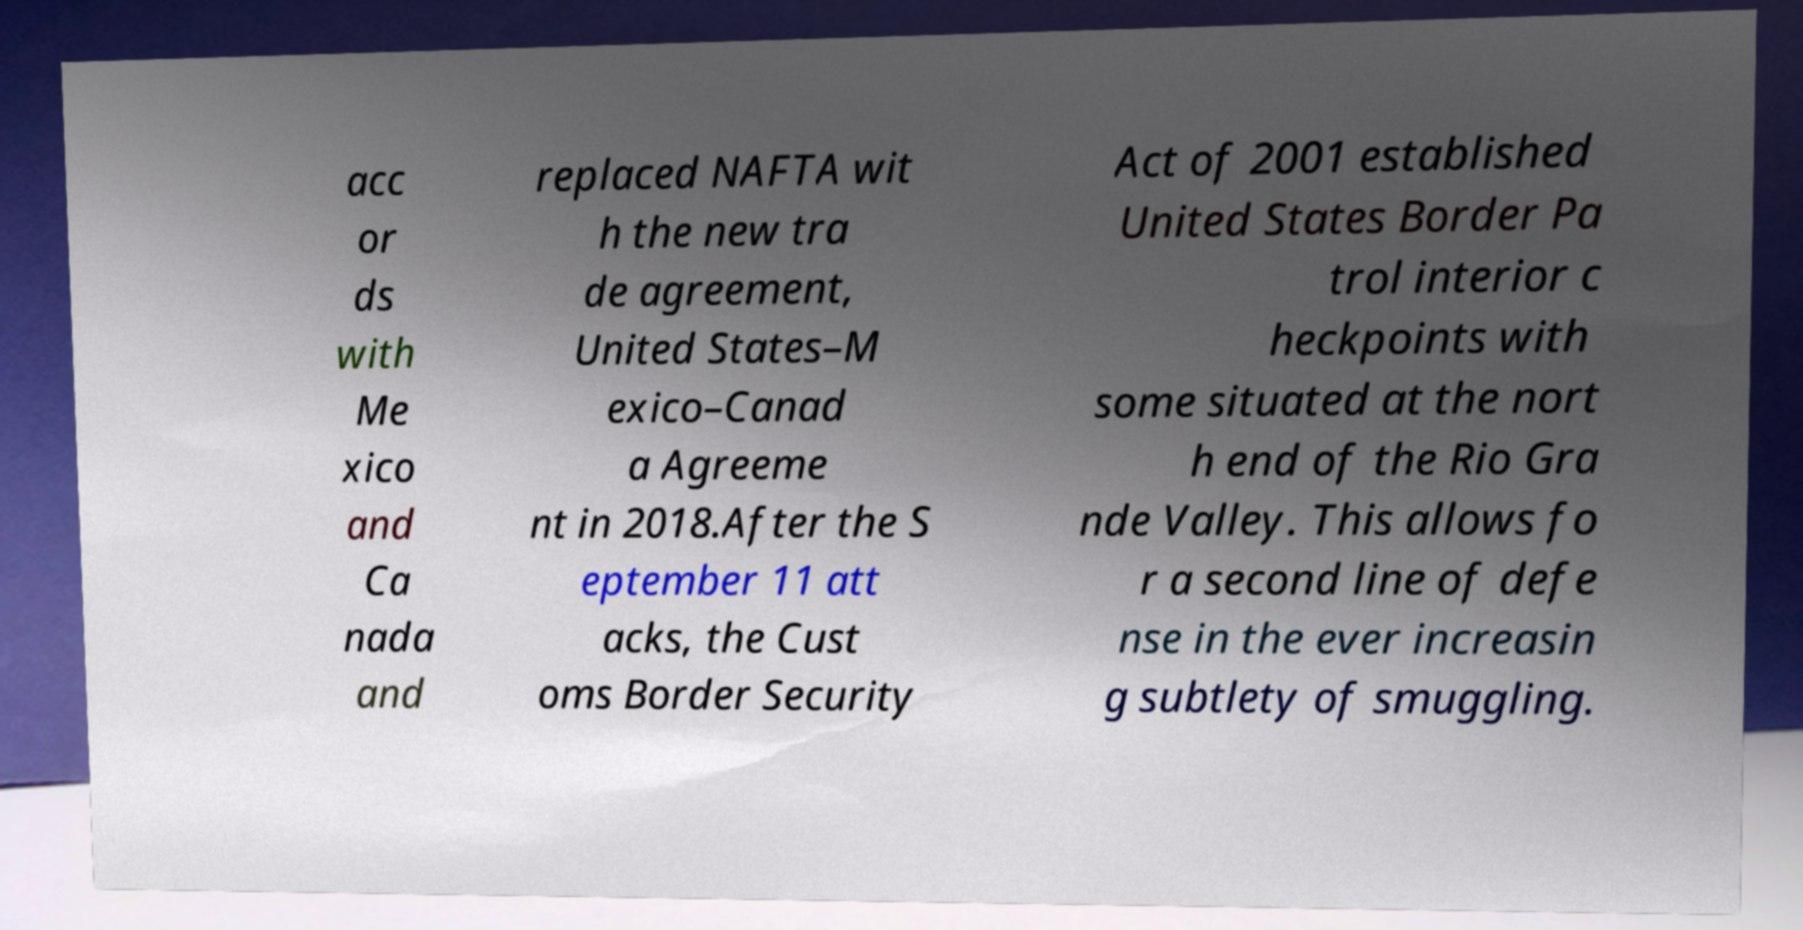For documentation purposes, I need the text within this image transcribed. Could you provide that? acc or ds with Me xico and Ca nada and replaced NAFTA wit h the new tra de agreement, United States–M exico–Canad a Agreeme nt in 2018.After the S eptember 11 att acks, the Cust oms Border Security Act of 2001 established United States Border Pa trol interior c heckpoints with some situated at the nort h end of the Rio Gra nde Valley. This allows fo r a second line of defe nse in the ever increasin g subtlety of smuggling. 